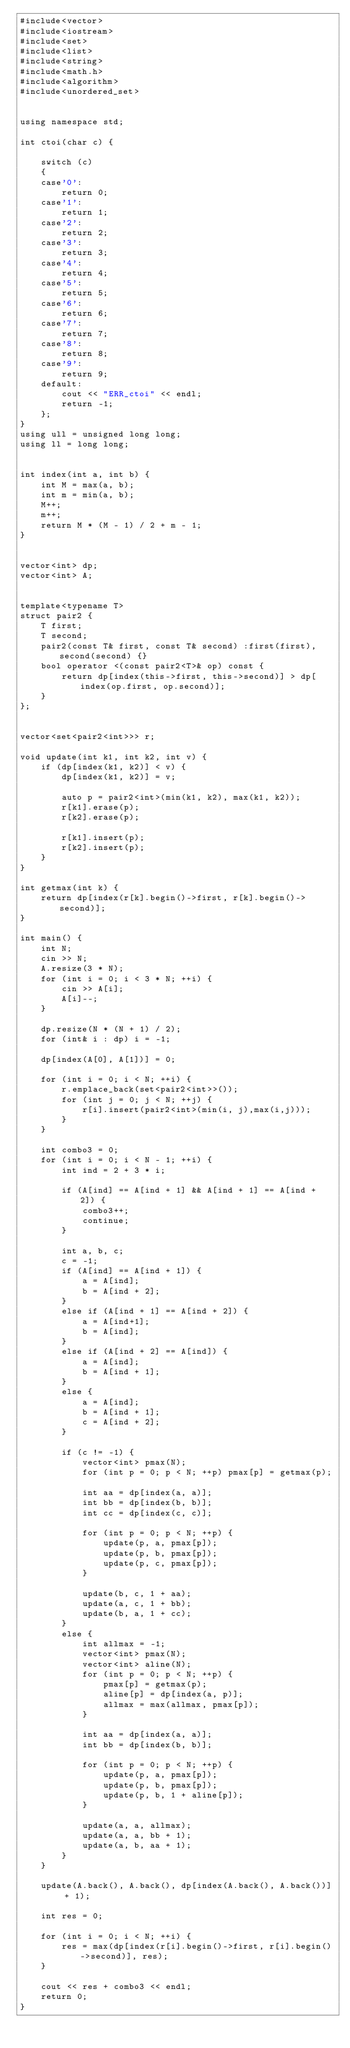Convert code to text. <code><loc_0><loc_0><loc_500><loc_500><_C++_>#include<vector>
#include<iostream>
#include<set>
#include<list>
#include<string>
#include<math.h>
#include<algorithm>
#include<unordered_set>


using namespace std;

int ctoi(char c) {

	switch (c)
	{
	case'0':
		return 0;
	case'1':
		return 1;
	case'2':
		return 2;
	case'3':
		return 3;
	case'4':
		return 4;
	case'5':
		return 5;
	case'6':
		return 6;
	case'7':
		return 7;
	case'8':
		return 8;
	case'9':
		return 9;
	default:
		cout << "ERR_ctoi" << endl;
		return -1;
	};
}
using ull = unsigned long long;
using ll = long long;


int index(int a, int b) {
	int M = max(a, b);
	int m = min(a, b);
	M++;
	m++;
	return M * (M - 1) / 2 + m - 1;
}


vector<int> dp;
vector<int> A;


template<typename T>
struct pair2 {
	T first;
	T second;
	pair2(const T& first, const T& second) :first(first), second(second) {}
	bool operator <(const pair2<T>& op) const {
		return dp[index(this->first, this->second)] > dp[index(op.first, op.second)];
	}
};


vector<set<pair2<int>>> r;

void update(int k1, int k2, int v) {
	if (dp[index(k1, k2)] < v) {
		dp[index(k1, k2)] = v;

		auto p = pair2<int>(min(k1, k2), max(k1, k2));
		r[k1].erase(p);
		r[k2].erase(p);

		r[k1].insert(p);
		r[k2].insert(p);
	}
}

int getmax(int k) {
	return dp[index(r[k].begin()->first, r[k].begin()->second)];
}

int main() {
	int N;
	cin >> N;
	A.resize(3 * N);
	for (int i = 0; i < 3 * N; ++i) {
		cin >> A[i];
		A[i]--;
	}

	dp.resize(N * (N + 1) / 2);
	for (int& i : dp) i = -1;

	dp[index(A[0], A[1])] = 0;

	for (int i = 0; i < N; ++i) {
		r.emplace_back(set<pair2<int>>());
		for (int j = 0; j < N; ++j) {
			r[i].insert(pair2<int>(min(i, j),max(i,j)));
		}
	}

	int combo3 = 0;
	for (int i = 0; i < N - 1; ++i) {
		int ind = 2 + 3 * i;

		if (A[ind] == A[ind + 1] && A[ind + 1] == A[ind + 2]) {
			combo3++;
			continue;
		}

		int a, b, c;
		c = -1;
		if (A[ind] == A[ind + 1]) {
			a = A[ind];
			b = A[ind + 2];
		}
		else if (A[ind + 1] == A[ind + 2]) {
			a = A[ind+1];
			b = A[ind];
		}
		else if (A[ind + 2] == A[ind]) {
			a = A[ind];
			b = A[ind + 1];
		}
		else {
			a = A[ind];
			b = A[ind + 1];
			c = A[ind + 2];
		}

		if (c != -1) {
			vector<int> pmax(N);
			for (int p = 0; p < N; ++p) pmax[p] = getmax(p);
			
			int aa = dp[index(a, a)];
			int bb = dp[index(b, b)];
			int cc = dp[index(c, c)];

			for (int p = 0; p < N; ++p) {
				update(p, a, pmax[p]);
				update(p, b, pmax[p]);
				update(p, c, pmax[p]);
			}

			update(b, c, 1 + aa);
			update(a, c, 1 + bb);
			update(b, a, 1 + cc);
		}
		else {
			int allmax = -1;
			vector<int> pmax(N);
			vector<int> aline(N);
			for (int p = 0; p < N; ++p) {
				pmax[p] = getmax(p);
				aline[p] = dp[index(a, p)];
				allmax = max(allmax, pmax[p]);
			}

			int aa = dp[index(a, a)];
			int bb = dp[index(b, b)];

			for (int p = 0; p < N; ++p) {
				update(p, a, pmax[p]);
				update(p, b, pmax[p]);
				update(p, b, 1 + aline[p]);
			}

			update(a, a, allmax);
			update(a, a, bb + 1);
			update(a, b, aa + 1);
		}
	}

	update(A.back(), A.back(), dp[index(A.back(), A.back())] + 1);

	int res = 0;

	for (int i = 0; i < N; ++i) {
		res = max(dp[index(r[i].begin()->first, r[i].begin()->second)], res);
	}

	cout << res + combo3 << endl;
	return 0;
}
</code> 